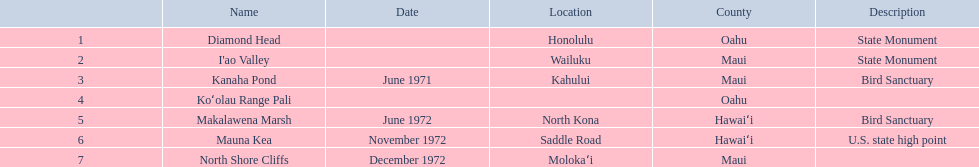Write the full table. {'header': ['', 'Name', 'Date', 'Location', 'County', 'Description'], 'rows': [['1', 'Diamond Head', '', 'Honolulu', 'Oahu', 'State Monument'], ['2', "I'ao Valley", '', 'Wailuku', 'Maui', 'State Monument'], ['3', 'Kanaha Pond', 'June 1971', 'Kahului', 'Maui', 'Bird Sanctuary'], ['4', 'Koʻolau Range Pali', '', '', 'Oahu', ''], ['5', 'Makalawena Marsh', 'June 1972', 'North Kona', 'Hawaiʻi', 'Bird Sanctuary'], ['6', 'Mauna Kea', 'November 1972', 'Saddle Road', 'Hawaiʻi', 'U.S. state high point'], ['7', 'North Shore Cliffs', 'December 1972', 'Molokaʻi', 'Maui', '']]} Which national natural landmarks in hawaii are located in oahu county? Diamond Head, Koʻolau Range Pali. From these landmarks, which one is documented without a location? Koʻolau Range Pali. 